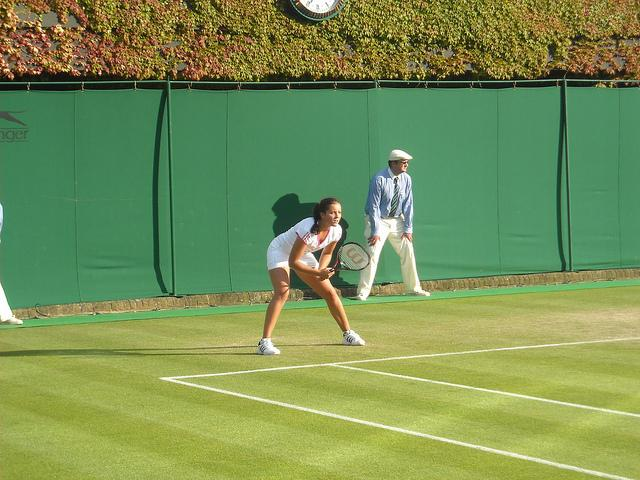Which shadow is the longest?

Choices:
A) pole
B) tennis racket
C) woman
D) man woman 